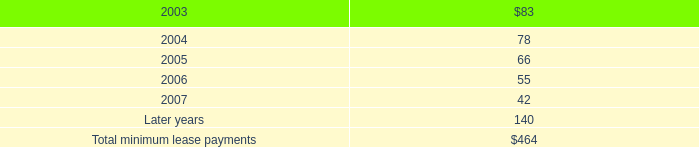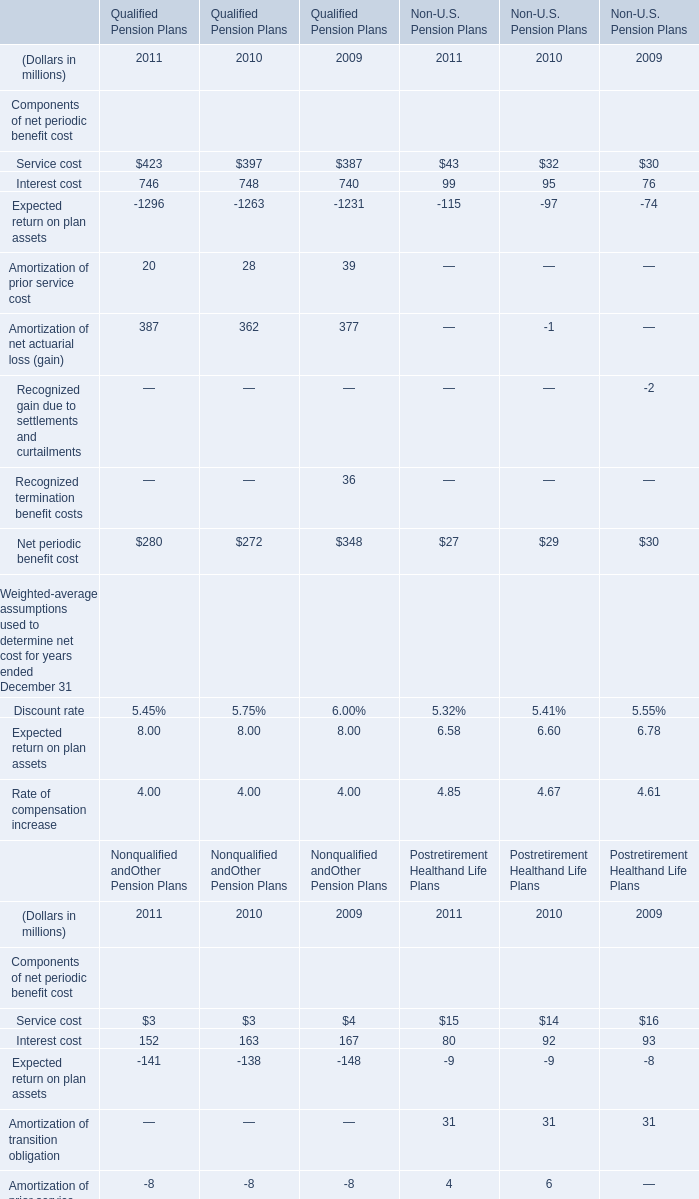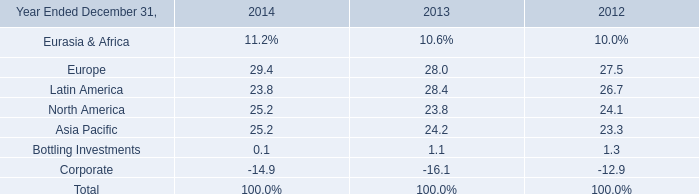How many Service cost for Nonqualified and Other Pension Plans exceeds the average of Europe in 2014? 
Answer: 0. 